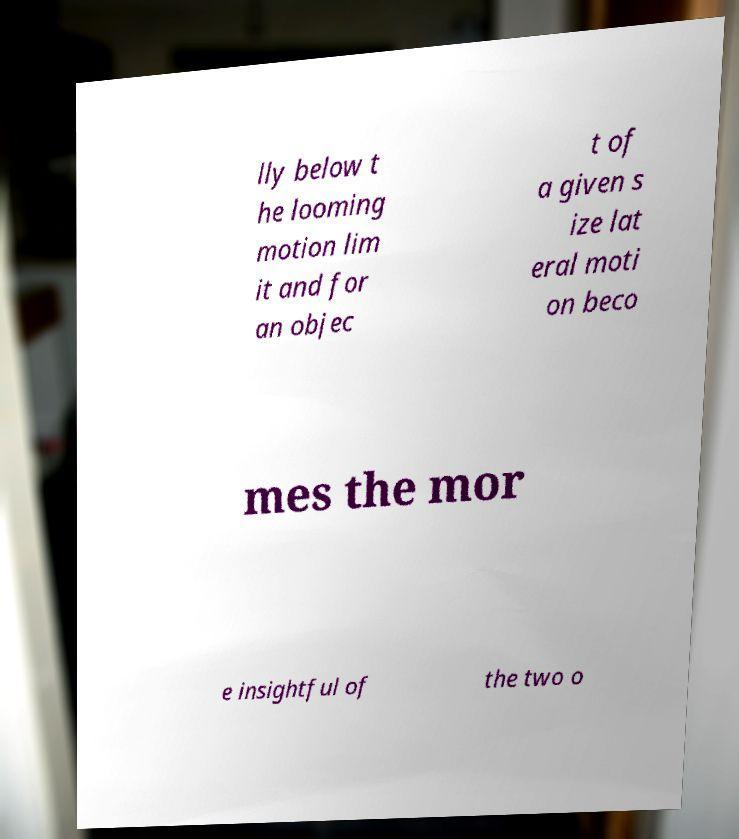Can you accurately transcribe the text from the provided image for me? lly below t he looming motion lim it and for an objec t of a given s ize lat eral moti on beco mes the mor e insightful of the two o 